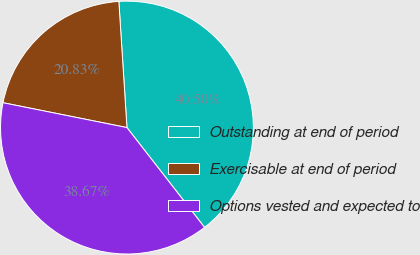Convert chart. <chart><loc_0><loc_0><loc_500><loc_500><pie_chart><fcel>Outstanding at end of period<fcel>Exercisable at end of period<fcel>Options vested and expected to<nl><fcel>40.5%<fcel>20.83%<fcel>38.67%<nl></chart> 